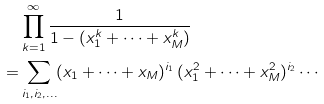Convert formula to latex. <formula><loc_0><loc_0><loc_500><loc_500>& \prod _ { k = 1 } ^ { \infty } \frac { 1 } { 1 - ( x _ { 1 } ^ { k } + \cdots + x _ { M } ^ { k } ) } \\ = & \sum _ { i _ { 1 } , i _ { 2 } , \dots } ( x _ { 1 } + \cdots + x _ { M } ) ^ { i _ { 1 } } \, ( x _ { 1 } ^ { 2 } + \cdots + x _ { M } ^ { 2 } ) ^ { i _ { 2 } } \cdots</formula> 